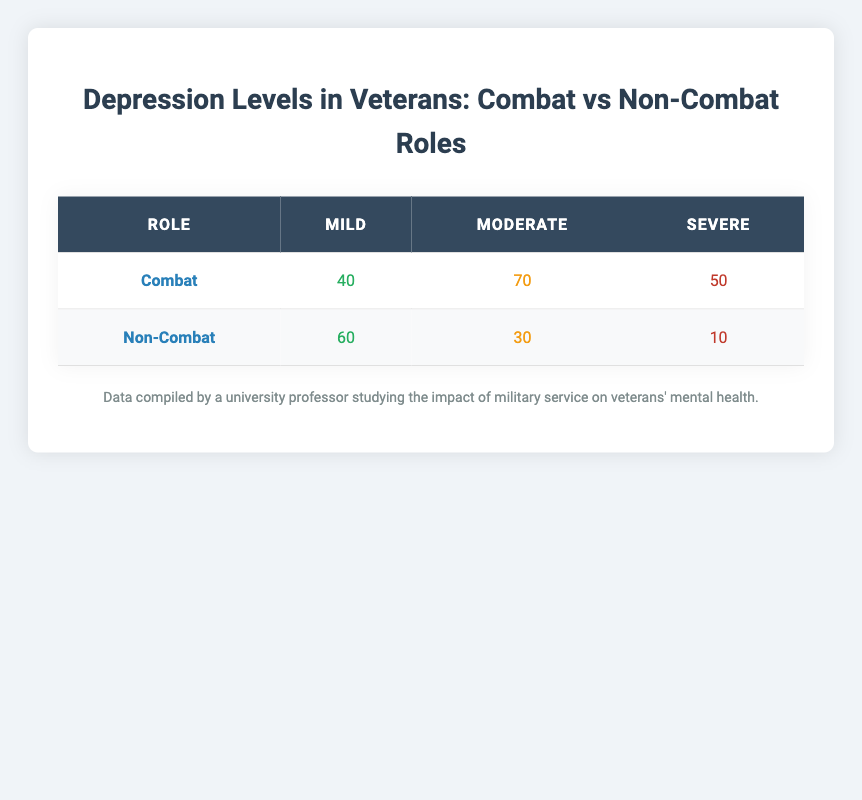What is the total number of combat veterans with severe depression? From the table, the severe depression count for combat veterans is 50. Therefore, the total number is simply 50.
Answer: 50 How many non-combat veterans reported moderate depression? Referring to the table, the count for non-combat veterans with moderate depression is 30.
Answer: 30 What is the sum of the mild depression counts for both roles? The mild counts are 40 for combat and 60 for non-combat. Summing them gives 40 + 60 = 100.
Answer: 100 Is there a higher incidence of severe depression among combat veterans than non-combat veterans? The count for severe depression among combat veterans is 50, whereas for non-combat veterans, it's 10. Since 50 > 10, the statement is true.
Answer: Yes What percentage of combat veterans experience mild depression? The total number of combat veterans is 40 (mild) + 70 (moderate) + 50 (severe) = 160. Mild counts are 40. The percentage is (40/160) * 100 = 25%.
Answer: 25% What is the difference in the number of veterans experiencing moderate depression between combat and non-combat roles? The count for moderate depression in combat veterans is 70, and for non-combat veterans, it’s 30. The difference is 70 - 30 = 40.
Answer: 40 